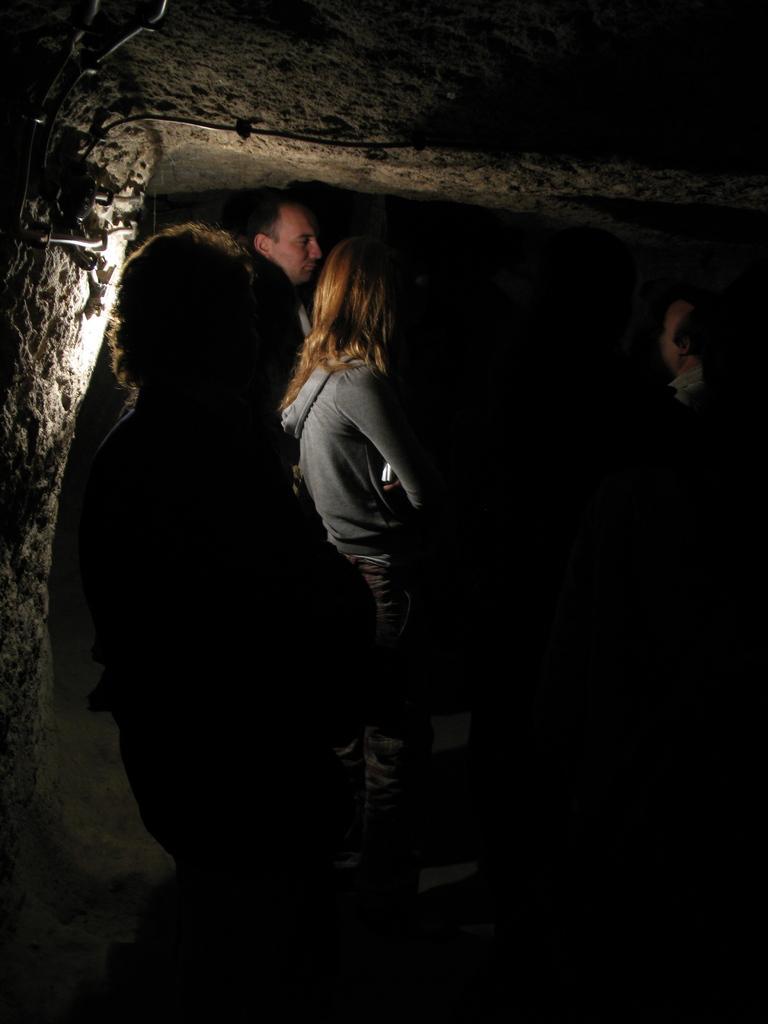Can you describe this image briefly? In this image I can see the group of people with the dresses. In the back I can see the wall. And I can see black image to the right. 